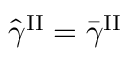<formula> <loc_0><loc_0><loc_500><loc_500>\hat { \gamma } ^ { I I } = \bar { \gamma } ^ { I I }</formula> 